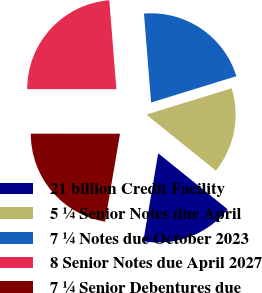Convert chart to OTSL. <chart><loc_0><loc_0><loc_500><loc_500><pie_chart><fcel>21 billion Credit Facility<fcel>5 ¼ Senior Notes due April<fcel>7 ¼ Notes due October 2023<fcel>8 Senior Notes due April 2027<fcel>7 ¼ Senior Debentures due<nl><fcel>16.87%<fcel>15.57%<fcel>21.5%<fcel>23.72%<fcel>22.33%<nl></chart> 